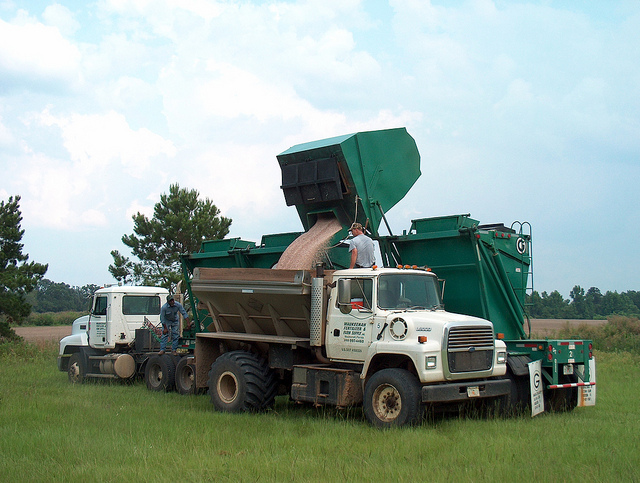Read and extract the text from this image. G 